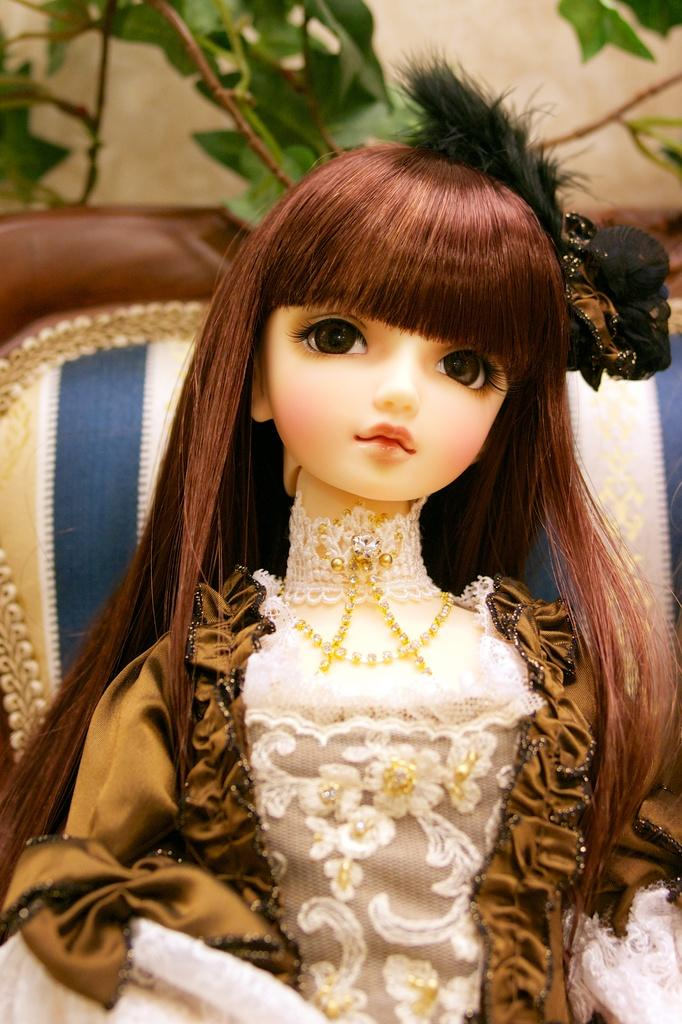What is the main subject of the image? There is a barbie doll in the image. Where is the barbie doll located? The barbie doll is on a chair. What can be seen in the background of the image? There is a wall and a plant in the background of the image. What type of pen is the barbie doll using to write a list in the image? There is no pen or list present in the image; the barbie doll is simply sitting on a chair. 